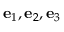<formula> <loc_0><loc_0><loc_500><loc_500>e _ { 1 } , e _ { 2 } , e _ { 3 }</formula> 